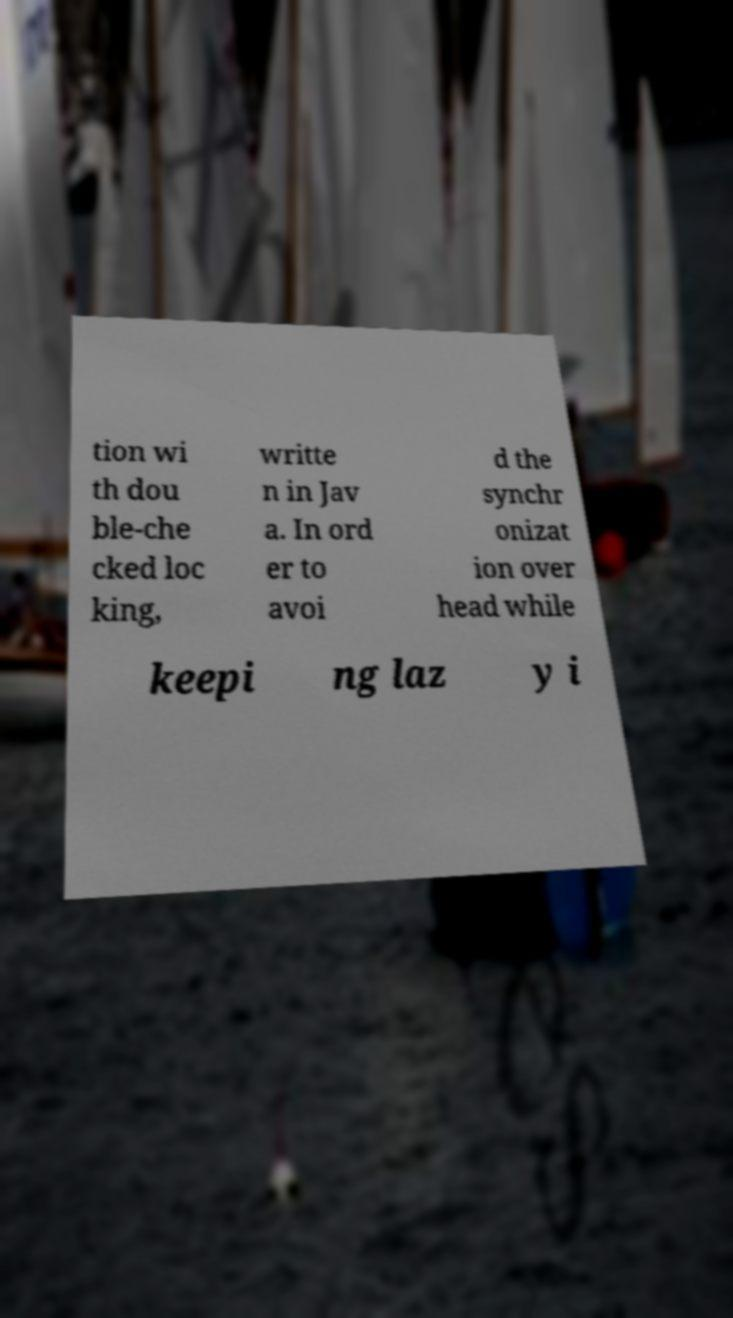For documentation purposes, I need the text within this image transcribed. Could you provide that? tion wi th dou ble-che cked loc king, writte n in Jav a. In ord er to avoi d the synchr onizat ion over head while keepi ng laz y i 